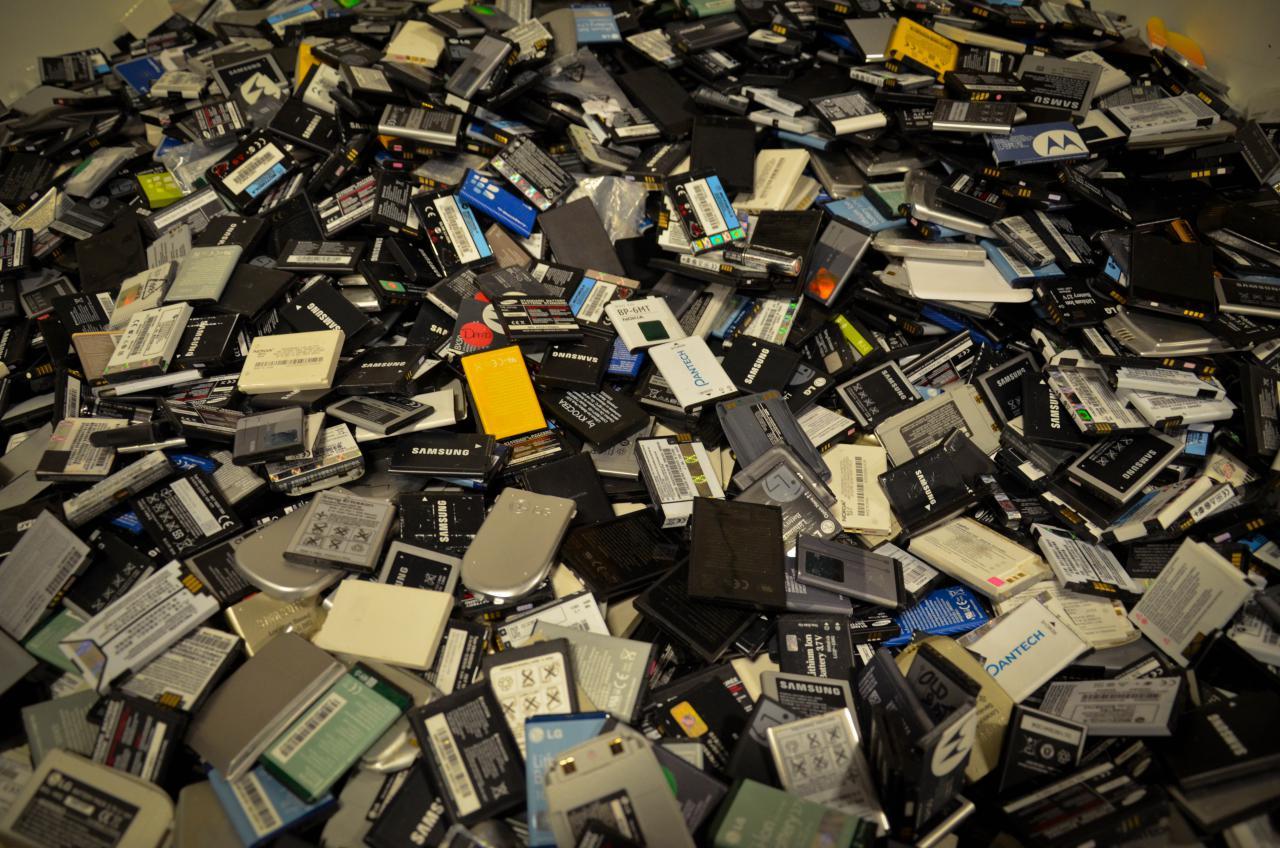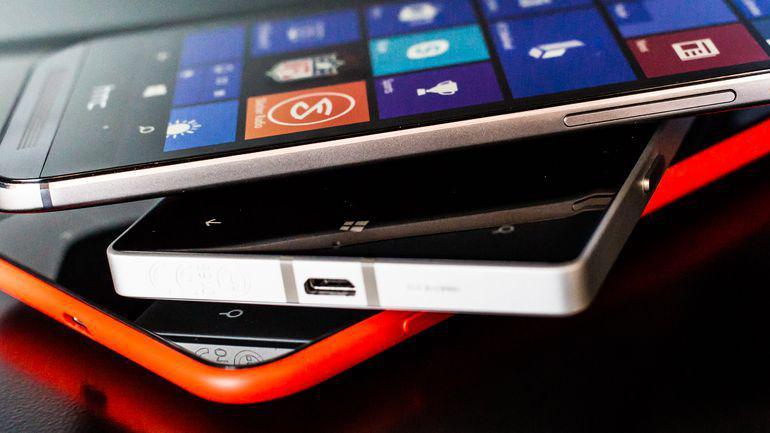The first image is the image on the left, the second image is the image on the right. For the images displayed, is the sentence "The phones in each of the image are stacked upon each other." factually correct? Answer yes or no. No. The first image is the image on the left, the second image is the image on the right. Examine the images to the left and right. Is the description "There are more phones in the left image than in the right image." accurate? Answer yes or no. Yes. 